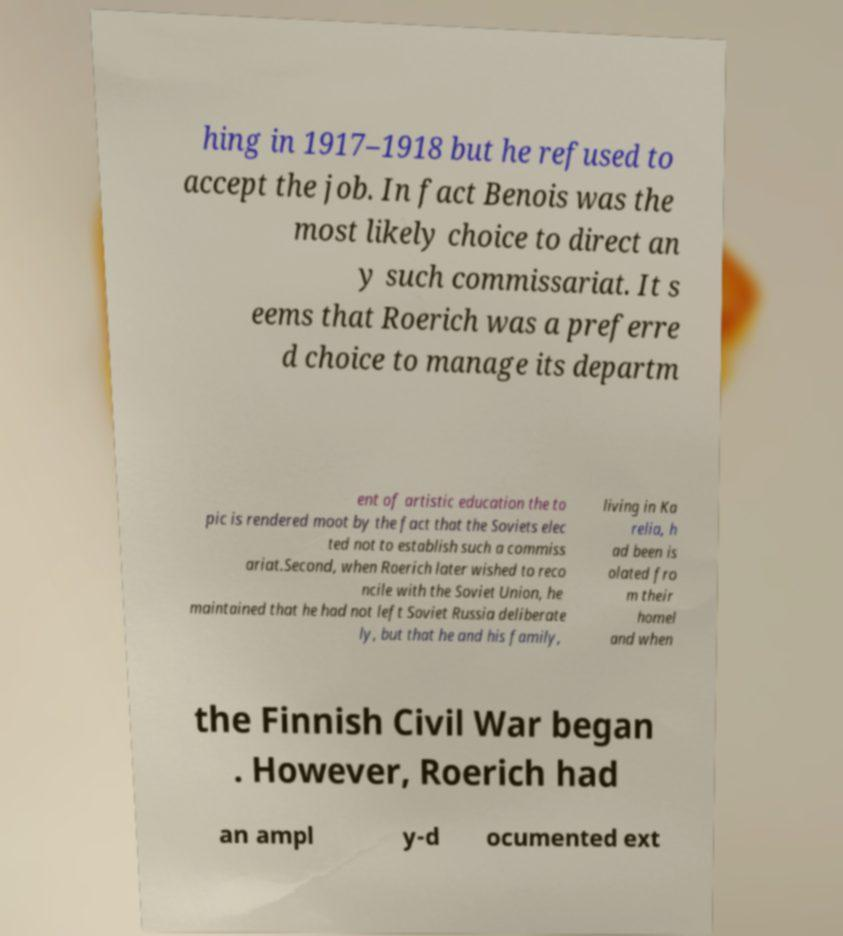I need the written content from this picture converted into text. Can you do that? hing in 1917–1918 but he refused to accept the job. In fact Benois was the most likely choice to direct an y such commissariat. It s eems that Roerich was a preferre d choice to manage its departm ent of artistic education the to pic is rendered moot by the fact that the Soviets elec ted not to establish such a commiss ariat.Second, when Roerich later wished to reco ncile with the Soviet Union, he maintained that he had not left Soviet Russia deliberate ly, but that he and his family, living in Ka relia, h ad been is olated fro m their homel and when the Finnish Civil War began . However, Roerich had an ampl y-d ocumented ext 